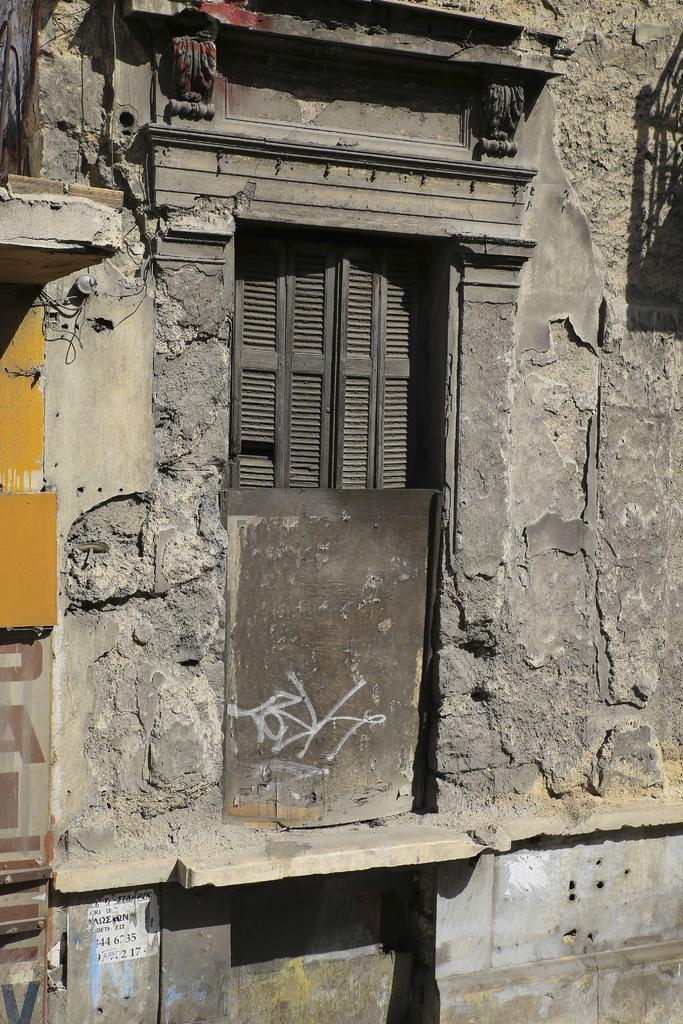What type of structure can be seen in the image? There is a wall in the image. Is there any opening in the wall? Yes, there is a window in the image. What is attached to the wall on the left side? There are boards attached to the wall on the left side. Can you see any pickles on the chair in the image? There is no chair or pickles present in the image. What type of produce is being sold in the image? There is no produce being sold in the image; it only features a wall, a window, and boards attached to the wall. 